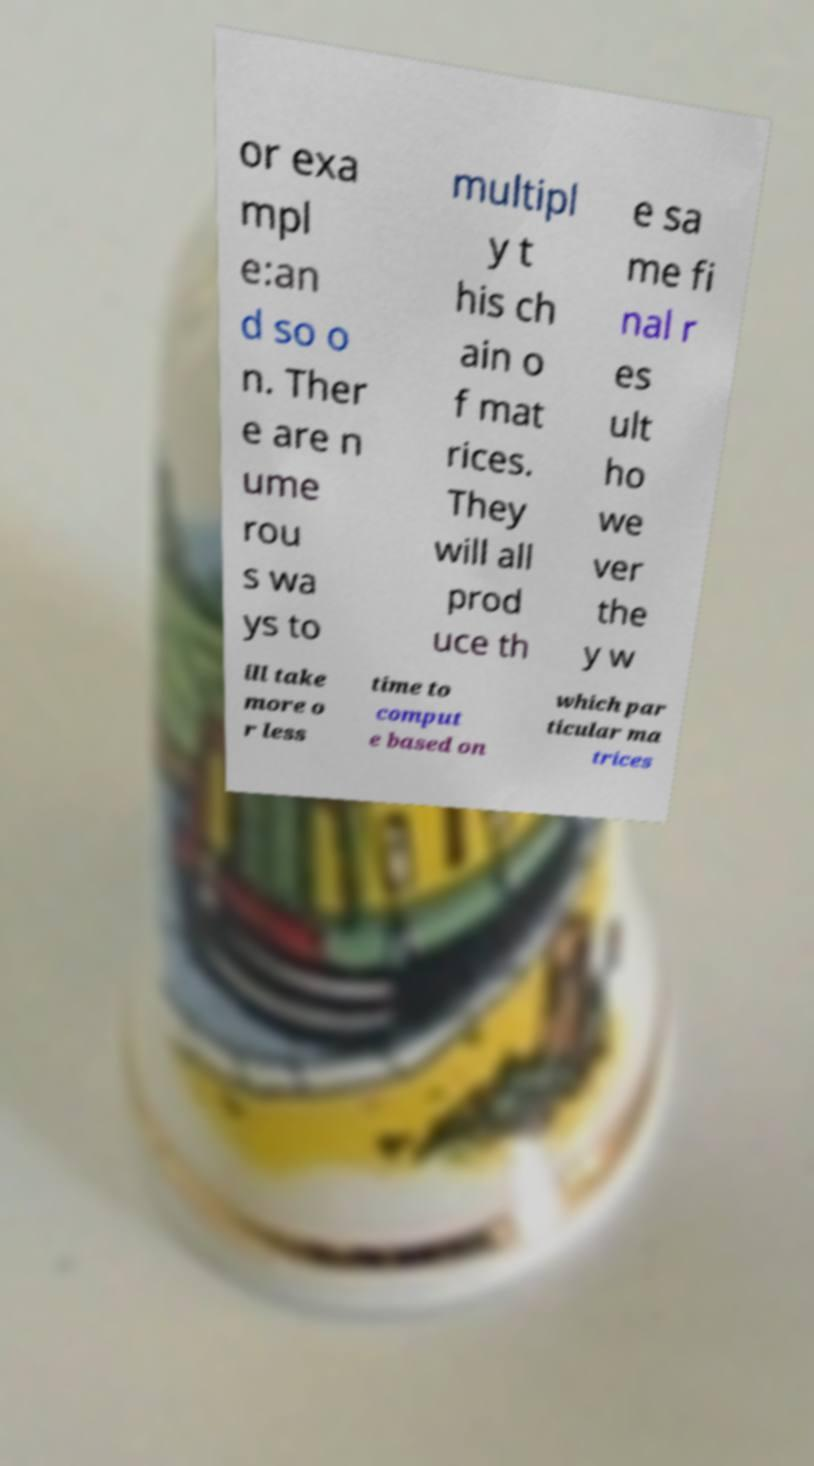Could you assist in decoding the text presented in this image and type it out clearly? or exa mpl e:an d so o n. Ther e are n ume rou s wa ys to multipl y t his ch ain o f mat rices. They will all prod uce th e sa me fi nal r es ult ho we ver the y w ill take more o r less time to comput e based on which par ticular ma trices 